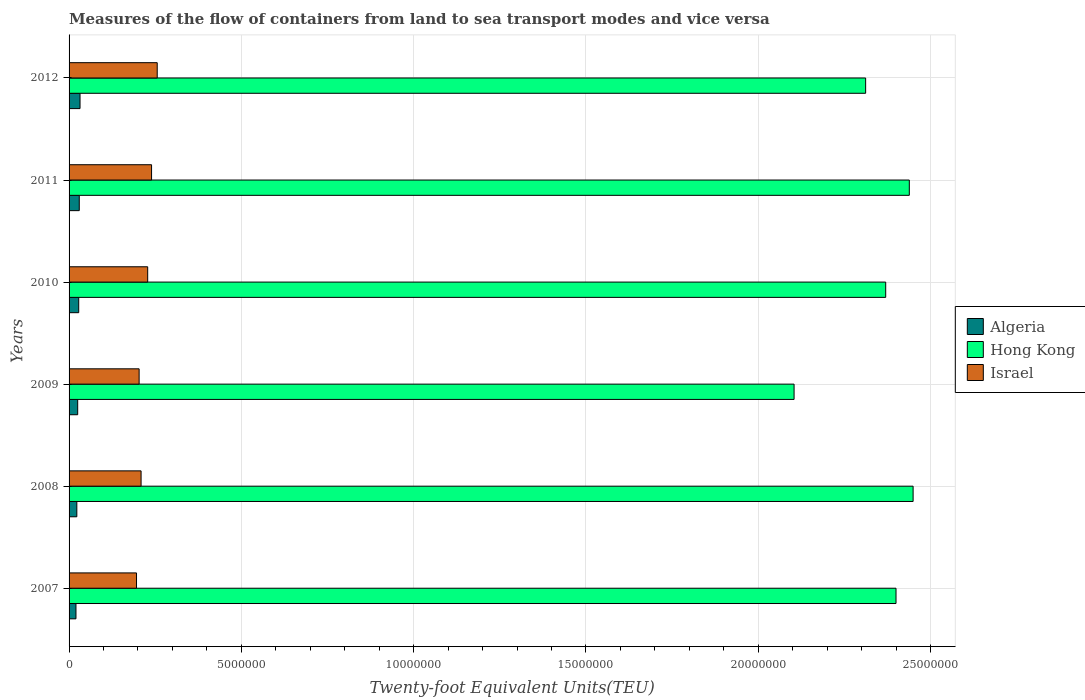How many different coloured bars are there?
Offer a terse response. 3. How many groups of bars are there?
Give a very brief answer. 6. Are the number of bars per tick equal to the number of legend labels?
Keep it short and to the point. Yes. How many bars are there on the 5th tick from the bottom?
Your response must be concise. 3. What is the label of the 6th group of bars from the top?
Provide a succinct answer. 2007. What is the container port traffic in Hong Kong in 2010?
Provide a short and direct response. 2.37e+07. Across all years, what is the maximum container port traffic in Algeria?
Your response must be concise. 3.18e+05. Across all years, what is the minimum container port traffic in Hong Kong?
Ensure brevity in your answer.  2.10e+07. What is the total container port traffic in Algeria in the graph?
Your answer should be compact. 1.57e+06. What is the difference between the container port traffic in Hong Kong in 2007 and that in 2011?
Provide a succinct answer. -3.86e+05. What is the difference between the container port traffic in Algeria in 2008 and the container port traffic in Israel in 2007?
Make the answer very short. -1.73e+06. What is the average container port traffic in Israel per year?
Provide a short and direct response. 2.22e+06. In the year 2010, what is the difference between the container port traffic in Hong Kong and container port traffic in Israel?
Provide a short and direct response. 2.14e+07. What is the ratio of the container port traffic in Israel in 2008 to that in 2011?
Offer a very short reply. 0.87. Is the difference between the container port traffic in Hong Kong in 2008 and 2011 greater than the difference between the container port traffic in Israel in 2008 and 2011?
Your answer should be compact. Yes. What is the difference between the highest and the second highest container port traffic in Algeria?
Your answer should be very brief. 2.22e+04. What is the difference between the highest and the lowest container port traffic in Hong Kong?
Offer a terse response. 3.45e+06. In how many years, is the container port traffic in Hong Kong greater than the average container port traffic in Hong Kong taken over all years?
Offer a very short reply. 4. What does the 2nd bar from the top in 2009 represents?
Your answer should be very brief. Hong Kong. What does the 3rd bar from the bottom in 2008 represents?
Offer a very short reply. Israel. Are all the bars in the graph horizontal?
Make the answer very short. Yes. What is the difference between two consecutive major ticks on the X-axis?
Your answer should be compact. 5.00e+06. Does the graph contain grids?
Your answer should be very brief. Yes. Where does the legend appear in the graph?
Ensure brevity in your answer.  Center right. How are the legend labels stacked?
Keep it short and to the point. Vertical. What is the title of the graph?
Offer a terse response. Measures of the flow of containers from land to sea transport modes and vice versa. What is the label or title of the X-axis?
Give a very brief answer. Twenty-foot Equivalent Units(TEU). What is the Twenty-foot Equivalent Units(TEU) in Algeria in 2007?
Offer a terse response. 2.00e+05. What is the Twenty-foot Equivalent Units(TEU) in Hong Kong in 2007?
Offer a terse response. 2.40e+07. What is the Twenty-foot Equivalent Units(TEU) in Israel in 2007?
Give a very brief answer. 1.96e+06. What is the Twenty-foot Equivalent Units(TEU) of Algeria in 2008?
Ensure brevity in your answer.  2.25e+05. What is the Twenty-foot Equivalent Units(TEU) in Hong Kong in 2008?
Offer a terse response. 2.45e+07. What is the Twenty-foot Equivalent Units(TEU) of Israel in 2008?
Give a very brief answer. 2.09e+06. What is the Twenty-foot Equivalent Units(TEU) of Algeria in 2009?
Provide a succinct answer. 2.50e+05. What is the Twenty-foot Equivalent Units(TEU) of Hong Kong in 2009?
Ensure brevity in your answer.  2.10e+07. What is the Twenty-foot Equivalent Units(TEU) of Israel in 2009?
Your response must be concise. 2.03e+06. What is the Twenty-foot Equivalent Units(TEU) in Algeria in 2010?
Provide a succinct answer. 2.80e+05. What is the Twenty-foot Equivalent Units(TEU) in Hong Kong in 2010?
Your answer should be compact. 2.37e+07. What is the Twenty-foot Equivalent Units(TEU) of Israel in 2010?
Offer a terse response. 2.28e+06. What is the Twenty-foot Equivalent Units(TEU) in Algeria in 2011?
Your response must be concise. 2.96e+05. What is the Twenty-foot Equivalent Units(TEU) of Hong Kong in 2011?
Offer a terse response. 2.44e+07. What is the Twenty-foot Equivalent Units(TEU) of Israel in 2011?
Give a very brief answer. 2.39e+06. What is the Twenty-foot Equivalent Units(TEU) of Algeria in 2012?
Ensure brevity in your answer.  3.18e+05. What is the Twenty-foot Equivalent Units(TEU) of Hong Kong in 2012?
Provide a short and direct response. 2.31e+07. What is the Twenty-foot Equivalent Units(TEU) of Israel in 2012?
Keep it short and to the point. 2.56e+06. Across all years, what is the maximum Twenty-foot Equivalent Units(TEU) in Algeria?
Keep it short and to the point. 3.18e+05. Across all years, what is the maximum Twenty-foot Equivalent Units(TEU) in Hong Kong?
Ensure brevity in your answer.  2.45e+07. Across all years, what is the maximum Twenty-foot Equivalent Units(TEU) in Israel?
Keep it short and to the point. 2.56e+06. Across all years, what is the minimum Twenty-foot Equivalent Units(TEU) of Algeria?
Make the answer very short. 2.00e+05. Across all years, what is the minimum Twenty-foot Equivalent Units(TEU) of Hong Kong?
Offer a terse response. 2.10e+07. Across all years, what is the minimum Twenty-foot Equivalent Units(TEU) in Israel?
Keep it short and to the point. 1.96e+06. What is the total Twenty-foot Equivalent Units(TEU) of Algeria in the graph?
Provide a short and direct response. 1.57e+06. What is the total Twenty-foot Equivalent Units(TEU) in Hong Kong in the graph?
Offer a terse response. 1.41e+08. What is the total Twenty-foot Equivalent Units(TEU) in Israel in the graph?
Your answer should be very brief. 1.33e+07. What is the difference between the Twenty-foot Equivalent Units(TEU) in Algeria in 2007 and that in 2008?
Ensure brevity in your answer.  -2.51e+04. What is the difference between the Twenty-foot Equivalent Units(TEU) in Hong Kong in 2007 and that in 2008?
Your response must be concise. -4.96e+05. What is the difference between the Twenty-foot Equivalent Units(TEU) in Israel in 2007 and that in 2008?
Give a very brief answer. -1.33e+05. What is the difference between the Twenty-foot Equivalent Units(TEU) in Algeria in 2007 and that in 2009?
Your response must be concise. -5.00e+04. What is the difference between the Twenty-foot Equivalent Units(TEU) in Hong Kong in 2007 and that in 2009?
Provide a succinct answer. 2.96e+06. What is the difference between the Twenty-foot Equivalent Units(TEU) in Israel in 2007 and that in 2009?
Your answer should be very brief. -7.57e+04. What is the difference between the Twenty-foot Equivalent Units(TEU) of Algeria in 2007 and that in 2010?
Offer a very short reply. -7.97e+04. What is the difference between the Twenty-foot Equivalent Units(TEU) in Hong Kong in 2007 and that in 2010?
Your answer should be very brief. 2.99e+05. What is the difference between the Twenty-foot Equivalent Units(TEU) in Israel in 2007 and that in 2010?
Keep it short and to the point. -3.24e+05. What is the difference between the Twenty-foot Equivalent Units(TEU) in Algeria in 2007 and that in 2011?
Offer a very short reply. -9.57e+04. What is the difference between the Twenty-foot Equivalent Units(TEU) in Hong Kong in 2007 and that in 2011?
Provide a short and direct response. -3.86e+05. What is the difference between the Twenty-foot Equivalent Units(TEU) in Israel in 2007 and that in 2011?
Provide a short and direct response. -4.37e+05. What is the difference between the Twenty-foot Equivalent Units(TEU) in Algeria in 2007 and that in 2012?
Make the answer very short. -1.18e+05. What is the difference between the Twenty-foot Equivalent Units(TEU) in Hong Kong in 2007 and that in 2012?
Keep it short and to the point. 8.81e+05. What is the difference between the Twenty-foot Equivalent Units(TEU) in Israel in 2007 and that in 2012?
Give a very brief answer. -6.01e+05. What is the difference between the Twenty-foot Equivalent Units(TEU) of Algeria in 2008 and that in 2009?
Make the answer very short. -2.50e+04. What is the difference between the Twenty-foot Equivalent Units(TEU) of Hong Kong in 2008 and that in 2009?
Your answer should be compact. 3.45e+06. What is the difference between the Twenty-foot Equivalent Units(TEU) of Israel in 2008 and that in 2009?
Your answer should be very brief. 5.69e+04. What is the difference between the Twenty-foot Equivalent Units(TEU) of Algeria in 2008 and that in 2010?
Ensure brevity in your answer.  -5.46e+04. What is the difference between the Twenty-foot Equivalent Units(TEU) in Hong Kong in 2008 and that in 2010?
Your answer should be very brief. 7.95e+05. What is the difference between the Twenty-foot Equivalent Units(TEU) in Israel in 2008 and that in 2010?
Provide a succinct answer. -1.92e+05. What is the difference between the Twenty-foot Equivalent Units(TEU) in Algeria in 2008 and that in 2011?
Give a very brief answer. -7.06e+04. What is the difference between the Twenty-foot Equivalent Units(TEU) in Hong Kong in 2008 and that in 2011?
Provide a short and direct response. 1.10e+05. What is the difference between the Twenty-foot Equivalent Units(TEU) of Israel in 2008 and that in 2011?
Provide a short and direct response. -3.04e+05. What is the difference between the Twenty-foot Equivalent Units(TEU) of Algeria in 2008 and that in 2012?
Make the answer very short. -9.28e+04. What is the difference between the Twenty-foot Equivalent Units(TEU) in Hong Kong in 2008 and that in 2012?
Your answer should be compact. 1.38e+06. What is the difference between the Twenty-foot Equivalent Units(TEU) in Israel in 2008 and that in 2012?
Provide a succinct answer. -4.68e+05. What is the difference between the Twenty-foot Equivalent Units(TEU) of Algeria in 2009 and that in 2010?
Your answer should be very brief. -2.97e+04. What is the difference between the Twenty-foot Equivalent Units(TEU) of Hong Kong in 2009 and that in 2010?
Your answer should be compact. -2.66e+06. What is the difference between the Twenty-foot Equivalent Units(TEU) in Israel in 2009 and that in 2010?
Ensure brevity in your answer.  -2.49e+05. What is the difference between the Twenty-foot Equivalent Units(TEU) of Algeria in 2009 and that in 2011?
Make the answer very short. -4.56e+04. What is the difference between the Twenty-foot Equivalent Units(TEU) of Hong Kong in 2009 and that in 2011?
Offer a terse response. -3.34e+06. What is the difference between the Twenty-foot Equivalent Units(TEU) of Israel in 2009 and that in 2011?
Offer a very short reply. -3.61e+05. What is the difference between the Twenty-foot Equivalent Units(TEU) in Algeria in 2009 and that in 2012?
Keep it short and to the point. -6.78e+04. What is the difference between the Twenty-foot Equivalent Units(TEU) of Hong Kong in 2009 and that in 2012?
Your answer should be very brief. -2.08e+06. What is the difference between the Twenty-foot Equivalent Units(TEU) of Israel in 2009 and that in 2012?
Your response must be concise. -5.25e+05. What is the difference between the Twenty-foot Equivalent Units(TEU) in Algeria in 2010 and that in 2011?
Your answer should be very brief. -1.59e+04. What is the difference between the Twenty-foot Equivalent Units(TEU) in Hong Kong in 2010 and that in 2011?
Make the answer very short. -6.85e+05. What is the difference between the Twenty-foot Equivalent Units(TEU) in Israel in 2010 and that in 2011?
Your answer should be compact. -1.12e+05. What is the difference between the Twenty-foot Equivalent Units(TEU) of Algeria in 2010 and that in 2012?
Make the answer very short. -3.81e+04. What is the difference between the Twenty-foot Equivalent Units(TEU) of Hong Kong in 2010 and that in 2012?
Make the answer very short. 5.82e+05. What is the difference between the Twenty-foot Equivalent Units(TEU) in Israel in 2010 and that in 2012?
Give a very brief answer. -2.77e+05. What is the difference between the Twenty-foot Equivalent Units(TEU) in Algeria in 2011 and that in 2012?
Your response must be concise. -2.22e+04. What is the difference between the Twenty-foot Equivalent Units(TEU) in Hong Kong in 2011 and that in 2012?
Your answer should be compact. 1.27e+06. What is the difference between the Twenty-foot Equivalent Units(TEU) of Israel in 2011 and that in 2012?
Your response must be concise. -1.64e+05. What is the difference between the Twenty-foot Equivalent Units(TEU) in Algeria in 2007 and the Twenty-foot Equivalent Units(TEU) in Hong Kong in 2008?
Provide a short and direct response. -2.43e+07. What is the difference between the Twenty-foot Equivalent Units(TEU) of Algeria in 2007 and the Twenty-foot Equivalent Units(TEU) of Israel in 2008?
Ensure brevity in your answer.  -1.89e+06. What is the difference between the Twenty-foot Equivalent Units(TEU) in Hong Kong in 2007 and the Twenty-foot Equivalent Units(TEU) in Israel in 2008?
Make the answer very short. 2.19e+07. What is the difference between the Twenty-foot Equivalent Units(TEU) in Algeria in 2007 and the Twenty-foot Equivalent Units(TEU) in Hong Kong in 2009?
Keep it short and to the point. -2.08e+07. What is the difference between the Twenty-foot Equivalent Units(TEU) of Algeria in 2007 and the Twenty-foot Equivalent Units(TEU) of Israel in 2009?
Offer a terse response. -1.83e+06. What is the difference between the Twenty-foot Equivalent Units(TEU) of Hong Kong in 2007 and the Twenty-foot Equivalent Units(TEU) of Israel in 2009?
Give a very brief answer. 2.20e+07. What is the difference between the Twenty-foot Equivalent Units(TEU) in Algeria in 2007 and the Twenty-foot Equivalent Units(TEU) in Hong Kong in 2010?
Give a very brief answer. -2.35e+07. What is the difference between the Twenty-foot Equivalent Units(TEU) in Algeria in 2007 and the Twenty-foot Equivalent Units(TEU) in Israel in 2010?
Ensure brevity in your answer.  -2.08e+06. What is the difference between the Twenty-foot Equivalent Units(TEU) of Hong Kong in 2007 and the Twenty-foot Equivalent Units(TEU) of Israel in 2010?
Make the answer very short. 2.17e+07. What is the difference between the Twenty-foot Equivalent Units(TEU) in Algeria in 2007 and the Twenty-foot Equivalent Units(TEU) in Hong Kong in 2011?
Your answer should be compact. -2.42e+07. What is the difference between the Twenty-foot Equivalent Units(TEU) of Algeria in 2007 and the Twenty-foot Equivalent Units(TEU) of Israel in 2011?
Give a very brief answer. -2.19e+06. What is the difference between the Twenty-foot Equivalent Units(TEU) in Hong Kong in 2007 and the Twenty-foot Equivalent Units(TEU) in Israel in 2011?
Give a very brief answer. 2.16e+07. What is the difference between the Twenty-foot Equivalent Units(TEU) of Algeria in 2007 and the Twenty-foot Equivalent Units(TEU) of Hong Kong in 2012?
Your answer should be very brief. -2.29e+07. What is the difference between the Twenty-foot Equivalent Units(TEU) in Algeria in 2007 and the Twenty-foot Equivalent Units(TEU) in Israel in 2012?
Provide a short and direct response. -2.36e+06. What is the difference between the Twenty-foot Equivalent Units(TEU) in Hong Kong in 2007 and the Twenty-foot Equivalent Units(TEU) in Israel in 2012?
Offer a very short reply. 2.14e+07. What is the difference between the Twenty-foot Equivalent Units(TEU) in Algeria in 2008 and the Twenty-foot Equivalent Units(TEU) in Hong Kong in 2009?
Offer a very short reply. -2.08e+07. What is the difference between the Twenty-foot Equivalent Units(TEU) in Algeria in 2008 and the Twenty-foot Equivalent Units(TEU) in Israel in 2009?
Your answer should be very brief. -1.81e+06. What is the difference between the Twenty-foot Equivalent Units(TEU) in Hong Kong in 2008 and the Twenty-foot Equivalent Units(TEU) in Israel in 2009?
Provide a short and direct response. 2.25e+07. What is the difference between the Twenty-foot Equivalent Units(TEU) in Algeria in 2008 and the Twenty-foot Equivalent Units(TEU) in Hong Kong in 2010?
Offer a very short reply. -2.35e+07. What is the difference between the Twenty-foot Equivalent Units(TEU) of Algeria in 2008 and the Twenty-foot Equivalent Units(TEU) of Israel in 2010?
Provide a short and direct response. -2.06e+06. What is the difference between the Twenty-foot Equivalent Units(TEU) of Hong Kong in 2008 and the Twenty-foot Equivalent Units(TEU) of Israel in 2010?
Offer a terse response. 2.22e+07. What is the difference between the Twenty-foot Equivalent Units(TEU) of Algeria in 2008 and the Twenty-foot Equivalent Units(TEU) of Hong Kong in 2011?
Offer a very short reply. -2.42e+07. What is the difference between the Twenty-foot Equivalent Units(TEU) of Algeria in 2008 and the Twenty-foot Equivalent Units(TEU) of Israel in 2011?
Provide a succinct answer. -2.17e+06. What is the difference between the Twenty-foot Equivalent Units(TEU) in Hong Kong in 2008 and the Twenty-foot Equivalent Units(TEU) in Israel in 2011?
Give a very brief answer. 2.21e+07. What is the difference between the Twenty-foot Equivalent Units(TEU) of Algeria in 2008 and the Twenty-foot Equivalent Units(TEU) of Hong Kong in 2012?
Provide a short and direct response. -2.29e+07. What is the difference between the Twenty-foot Equivalent Units(TEU) of Algeria in 2008 and the Twenty-foot Equivalent Units(TEU) of Israel in 2012?
Ensure brevity in your answer.  -2.33e+06. What is the difference between the Twenty-foot Equivalent Units(TEU) of Hong Kong in 2008 and the Twenty-foot Equivalent Units(TEU) of Israel in 2012?
Offer a terse response. 2.19e+07. What is the difference between the Twenty-foot Equivalent Units(TEU) in Algeria in 2009 and the Twenty-foot Equivalent Units(TEU) in Hong Kong in 2010?
Provide a short and direct response. -2.34e+07. What is the difference between the Twenty-foot Equivalent Units(TEU) of Algeria in 2009 and the Twenty-foot Equivalent Units(TEU) of Israel in 2010?
Provide a succinct answer. -2.03e+06. What is the difference between the Twenty-foot Equivalent Units(TEU) in Hong Kong in 2009 and the Twenty-foot Equivalent Units(TEU) in Israel in 2010?
Give a very brief answer. 1.88e+07. What is the difference between the Twenty-foot Equivalent Units(TEU) of Algeria in 2009 and the Twenty-foot Equivalent Units(TEU) of Hong Kong in 2011?
Ensure brevity in your answer.  -2.41e+07. What is the difference between the Twenty-foot Equivalent Units(TEU) in Algeria in 2009 and the Twenty-foot Equivalent Units(TEU) in Israel in 2011?
Your answer should be very brief. -2.14e+06. What is the difference between the Twenty-foot Equivalent Units(TEU) in Hong Kong in 2009 and the Twenty-foot Equivalent Units(TEU) in Israel in 2011?
Your answer should be compact. 1.86e+07. What is the difference between the Twenty-foot Equivalent Units(TEU) in Algeria in 2009 and the Twenty-foot Equivalent Units(TEU) in Hong Kong in 2012?
Ensure brevity in your answer.  -2.29e+07. What is the difference between the Twenty-foot Equivalent Units(TEU) in Algeria in 2009 and the Twenty-foot Equivalent Units(TEU) in Israel in 2012?
Your response must be concise. -2.31e+06. What is the difference between the Twenty-foot Equivalent Units(TEU) in Hong Kong in 2009 and the Twenty-foot Equivalent Units(TEU) in Israel in 2012?
Your response must be concise. 1.85e+07. What is the difference between the Twenty-foot Equivalent Units(TEU) of Algeria in 2010 and the Twenty-foot Equivalent Units(TEU) of Hong Kong in 2011?
Make the answer very short. -2.41e+07. What is the difference between the Twenty-foot Equivalent Units(TEU) in Algeria in 2010 and the Twenty-foot Equivalent Units(TEU) in Israel in 2011?
Ensure brevity in your answer.  -2.11e+06. What is the difference between the Twenty-foot Equivalent Units(TEU) in Hong Kong in 2010 and the Twenty-foot Equivalent Units(TEU) in Israel in 2011?
Make the answer very short. 2.13e+07. What is the difference between the Twenty-foot Equivalent Units(TEU) in Algeria in 2010 and the Twenty-foot Equivalent Units(TEU) in Hong Kong in 2012?
Provide a succinct answer. -2.28e+07. What is the difference between the Twenty-foot Equivalent Units(TEU) in Algeria in 2010 and the Twenty-foot Equivalent Units(TEU) in Israel in 2012?
Provide a short and direct response. -2.28e+06. What is the difference between the Twenty-foot Equivalent Units(TEU) of Hong Kong in 2010 and the Twenty-foot Equivalent Units(TEU) of Israel in 2012?
Make the answer very short. 2.11e+07. What is the difference between the Twenty-foot Equivalent Units(TEU) in Algeria in 2011 and the Twenty-foot Equivalent Units(TEU) in Hong Kong in 2012?
Your response must be concise. -2.28e+07. What is the difference between the Twenty-foot Equivalent Units(TEU) of Algeria in 2011 and the Twenty-foot Equivalent Units(TEU) of Israel in 2012?
Ensure brevity in your answer.  -2.26e+06. What is the difference between the Twenty-foot Equivalent Units(TEU) in Hong Kong in 2011 and the Twenty-foot Equivalent Units(TEU) in Israel in 2012?
Ensure brevity in your answer.  2.18e+07. What is the average Twenty-foot Equivalent Units(TEU) of Algeria per year?
Provide a short and direct response. 2.61e+05. What is the average Twenty-foot Equivalent Units(TEU) of Hong Kong per year?
Your answer should be compact. 2.35e+07. What is the average Twenty-foot Equivalent Units(TEU) in Israel per year?
Give a very brief answer. 2.22e+06. In the year 2007, what is the difference between the Twenty-foot Equivalent Units(TEU) in Algeria and Twenty-foot Equivalent Units(TEU) in Hong Kong?
Offer a terse response. -2.38e+07. In the year 2007, what is the difference between the Twenty-foot Equivalent Units(TEU) of Algeria and Twenty-foot Equivalent Units(TEU) of Israel?
Your answer should be very brief. -1.76e+06. In the year 2007, what is the difference between the Twenty-foot Equivalent Units(TEU) of Hong Kong and Twenty-foot Equivalent Units(TEU) of Israel?
Your response must be concise. 2.20e+07. In the year 2008, what is the difference between the Twenty-foot Equivalent Units(TEU) in Algeria and Twenty-foot Equivalent Units(TEU) in Hong Kong?
Make the answer very short. -2.43e+07. In the year 2008, what is the difference between the Twenty-foot Equivalent Units(TEU) of Algeria and Twenty-foot Equivalent Units(TEU) of Israel?
Your answer should be compact. -1.86e+06. In the year 2008, what is the difference between the Twenty-foot Equivalent Units(TEU) in Hong Kong and Twenty-foot Equivalent Units(TEU) in Israel?
Offer a terse response. 2.24e+07. In the year 2009, what is the difference between the Twenty-foot Equivalent Units(TEU) in Algeria and Twenty-foot Equivalent Units(TEU) in Hong Kong?
Offer a terse response. -2.08e+07. In the year 2009, what is the difference between the Twenty-foot Equivalent Units(TEU) of Algeria and Twenty-foot Equivalent Units(TEU) of Israel?
Your response must be concise. -1.78e+06. In the year 2009, what is the difference between the Twenty-foot Equivalent Units(TEU) of Hong Kong and Twenty-foot Equivalent Units(TEU) of Israel?
Your answer should be compact. 1.90e+07. In the year 2010, what is the difference between the Twenty-foot Equivalent Units(TEU) of Algeria and Twenty-foot Equivalent Units(TEU) of Hong Kong?
Your answer should be compact. -2.34e+07. In the year 2010, what is the difference between the Twenty-foot Equivalent Units(TEU) in Algeria and Twenty-foot Equivalent Units(TEU) in Israel?
Your answer should be very brief. -2.00e+06. In the year 2010, what is the difference between the Twenty-foot Equivalent Units(TEU) of Hong Kong and Twenty-foot Equivalent Units(TEU) of Israel?
Keep it short and to the point. 2.14e+07. In the year 2011, what is the difference between the Twenty-foot Equivalent Units(TEU) of Algeria and Twenty-foot Equivalent Units(TEU) of Hong Kong?
Ensure brevity in your answer.  -2.41e+07. In the year 2011, what is the difference between the Twenty-foot Equivalent Units(TEU) of Algeria and Twenty-foot Equivalent Units(TEU) of Israel?
Your answer should be very brief. -2.10e+06. In the year 2011, what is the difference between the Twenty-foot Equivalent Units(TEU) in Hong Kong and Twenty-foot Equivalent Units(TEU) in Israel?
Offer a very short reply. 2.20e+07. In the year 2012, what is the difference between the Twenty-foot Equivalent Units(TEU) of Algeria and Twenty-foot Equivalent Units(TEU) of Hong Kong?
Offer a very short reply. -2.28e+07. In the year 2012, what is the difference between the Twenty-foot Equivalent Units(TEU) in Algeria and Twenty-foot Equivalent Units(TEU) in Israel?
Offer a terse response. -2.24e+06. In the year 2012, what is the difference between the Twenty-foot Equivalent Units(TEU) of Hong Kong and Twenty-foot Equivalent Units(TEU) of Israel?
Give a very brief answer. 2.06e+07. What is the ratio of the Twenty-foot Equivalent Units(TEU) of Algeria in 2007 to that in 2008?
Provide a short and direct response. 0.89. What is the ratio of the Twenty-foot Equivalent Units(TEU) of Hong Kong in 2007 to that in 2008?
Make the answer very short. 0.98. What is the ratio of the Twenty-foot Equivalent Units(TEU) in Israel in 2007 to that in 2008?
Give a very brief answer. 0.94. What is the ratio of the Twenty-foot Equivalent Units(TEU) of Algeria in 2007 to that in 2009?
Offer a terse response. 0.8. What is the ratio of the Twenty-foot Equivalent Units(TEU) of Hong Kong in 2007 to that in 2009?
Offer a very short reply. 1.14. What is the ratio of the Twenty-foot Equivalent Units(TEU) in Israel in 2007 to that in 2009?
Offer a terse response. 0.96. What is the ratio of the Twenty-foot Equivalent Units(TEU) of Algeria in 2007 to that in 2010?
Provide a short and direct response. 0.71. What is the ratio of the Twenty-foot Equivalent Units(TEU) in Hong Kong in 2007 to that in 2010?
Keep it short and to the point. 1.01. What is the ratio of the Twenty-foot Equivalent Units(TEU) of Israel in 2007 to that in 2010?
Provide a succinct answer. 0.86. What is the ratio of the Twenty-foot Equivalent Units(TEU) in Algeria in 2007 to that in 2011?
Give a very brief answer. 0.68. What is the ratio of the Twenty-foot Equivalent Units(TEU) of Hong Kong in 2007 to that in 2011?
Offer a very short reply. 0.98. What is the ratio of the Twenty-foot Equivalent Units(TEU) in Israel in 2007 to that in 2011?
Your answer should be compact. 0.82. What is the ratio of the Twenty-foot Equivalent Units(TEU) of Algeria in 2007 to that in 2012?
Make the answer very short. 0.63. What is the ratio of the Twenty-foot Equivalent Units(TEU) of Hong Kong in 2007 to that in 2012?
Give a very brief answer. 1.04. What is the ratio of the Twenty-foot Equivalent Units(TEU) of Israel in 2007 to that in 2012?
Your answer should be compact. 0.77. What is the ratio of the Twenty-foot Equivalent Units(TEU) of Algeria in 2008 to that in 2009?
Offer a very short reply. 0.9. What is the ratio of the Twenty-foot Equivalent Units(TEU) in Hong Kong in 2008 to that in 2009?
Keep it short and to the point. 1.16. What is the ratio of the Twenty-foot Equivalent Units(TEU) of Israel in 2008 to that in 2009?
Provide a succinct answer. 1.03. What is the ratio of the Twenty-foot Equivalent Units(TEU) of Algeria in 2008 to that in 2010?
Your answer should be very brief. 0.8. What is the ratio of the Twenty-foot Equivalent Units(TEU) of Hong Kong in 2008 to that in 2010?
Your answer should be compact. 1.03. What is the ratio of the Twenty-foot Equivalent Units(TEU) in Israel in 2008 to that in 2010?
Make the answer very short. 0.92. What is the ratio of the Twenty-foot Equivalent Units(TEU) of Algeria in 2008 to that in 2011?
Make the answer very short. 0.76. What is the ratio of the Twenty-foot Equivalent Units(TEU) of Israel in 2008 to that in 2011?
Your response must be concise. 0.87. What is the ratio of the Twenty-foot Equivalent Units(TEU) in Algeria in 2008 to that in 2012?
Give a very brief answer. 0.71. What is the ratio of the Twenty-foot Equivalent Units(TEU) of Hong Kong in 2008 to that in 2012?
Ensure brevity in your answer.  1.06. What is the ratio of the Twenty-foot Equivalent Units(TEU) in Israel in 2008 to that in 2012?
Offer a terse response. 0.82. What is the ratio of the Twenty-foot Equivalent Units(TEU) of Algeria in 2009 to that in 2010?
Your answer should be very brief. 0.89. What is the ratio of the Twenty-foot Equivalent Units(TEU) in Hong Kong in 2009 to that in 2010?
Provide a short and direct response. 0.89. What is the ratio of the Twenty-foot Equivalent Units(TEU) in Israel in 2009 to that in 2010?
Keep it short and to the point. 0.89. What is the ratio of the Twenty-foot Equivalent Units(TEU) of Algeria in 2009 to that in 2011?
Your answer should be compact. 0.85. What is the ratio of the Twenty-foot Equivalent Units(TEU) of Hong Kong in 2009 to that in 2011?
Keep it short and to the point. 0.86. What is the ratio of the Twenty-foot Equivalent Units(TEU) in Israel in 2009 to that in 2011?
Keep it short and to the point. 0.85. What is the ratio of the Twenty-foot Equivalent Units(TEU) in Algeria in 2009 to that in 2012?
Provide a succinct answer. 0.79. What is the ratio of the Twenty-foot Equivalent Units(TEU) in Hong Kong in 2009 to that in 2012?
Your response must be concise. 0.91. What is the ratio of the Twenty-foot Equivalent Units(TEU) of Israel in 2009 to that in 2012?
Your answer should be compact. 0.79. What is the ratio of the Twenty-foot Equivalent Units(TEU) in Algeria in 2010 to that in 2011?
Give a very brief answer. 0.95. What is the ratio of the Twenty-foot Equivalent Units(TEU) of Hong Kong in 2010 to that in 2011?
Provide a short and direct response. 0.97. What is the ratio of the Twenty-foot Equivalent Units(TEU) of Israel in 2010 to that in 2011?
Your answer should be very brief. 0.95. What is the ratio of the Twenty-foot Equivalent Units(TEU) of Algeria in 2010 to that in 2012?
Provide a succinct answer. 0.88. What is the ratio of the Twenty-foot Equivalent Units(TEU) in Hong Kong in 2010 to that in 2012?
Give a very brief answer. 1.03. What is the ratio of the Twenty-foot Equivalent Units(TEU) in Israel in 2010 to that in 2012?
Make the answer very short. 0.89. What is the ratio of the Twenty-foot Equivalent Units(TEU) of Algeria in 2011 to that in 2012?
Your answer should be compact. 0.93. What is the ratio of the Twenty-foot Equivalent Units(TEU) of Hong Kong in 2011 to that in 2012?
Provide a short and direct response. 1.05. What is the ratio of the Twenty-foot Equivalent Units(TEU) of Israel in 2011 to that in 2012?
Provide a succinct answer. 0.94. What is the difference between the highest and the second highest Twenty-foot Equivalent Units(TEU) in Algeria?
Keep it short and to the point. 2.22e+04. What is the difference between the highest and the second highest Twenty-foot Equivalent Units(TEU) of Hong Kong?
Keep it short and to the point. 1.10e+05. What is the difference between the highest and the second highest Twenty-foot Equivalent Units(TEU) in Israel?
Your answer should be very brief. 1.64e+05. What is the difference between the highest and the lowest Twenty-foot Equivalent Units(TEU) in Algeria?
Ensure brevity in your answer.  1.18e+05. What is the difference between the highest and the lowest Twenty-foot Equivalent Units(TEU) of Hong Kong?
Your response must be concise. 3.45e+06. What is the difference between the highest and the lowest Twenty-foot Equivalent Units(TEU) in Israel?
Ensure brevity in your answer.  6.01e+05. 